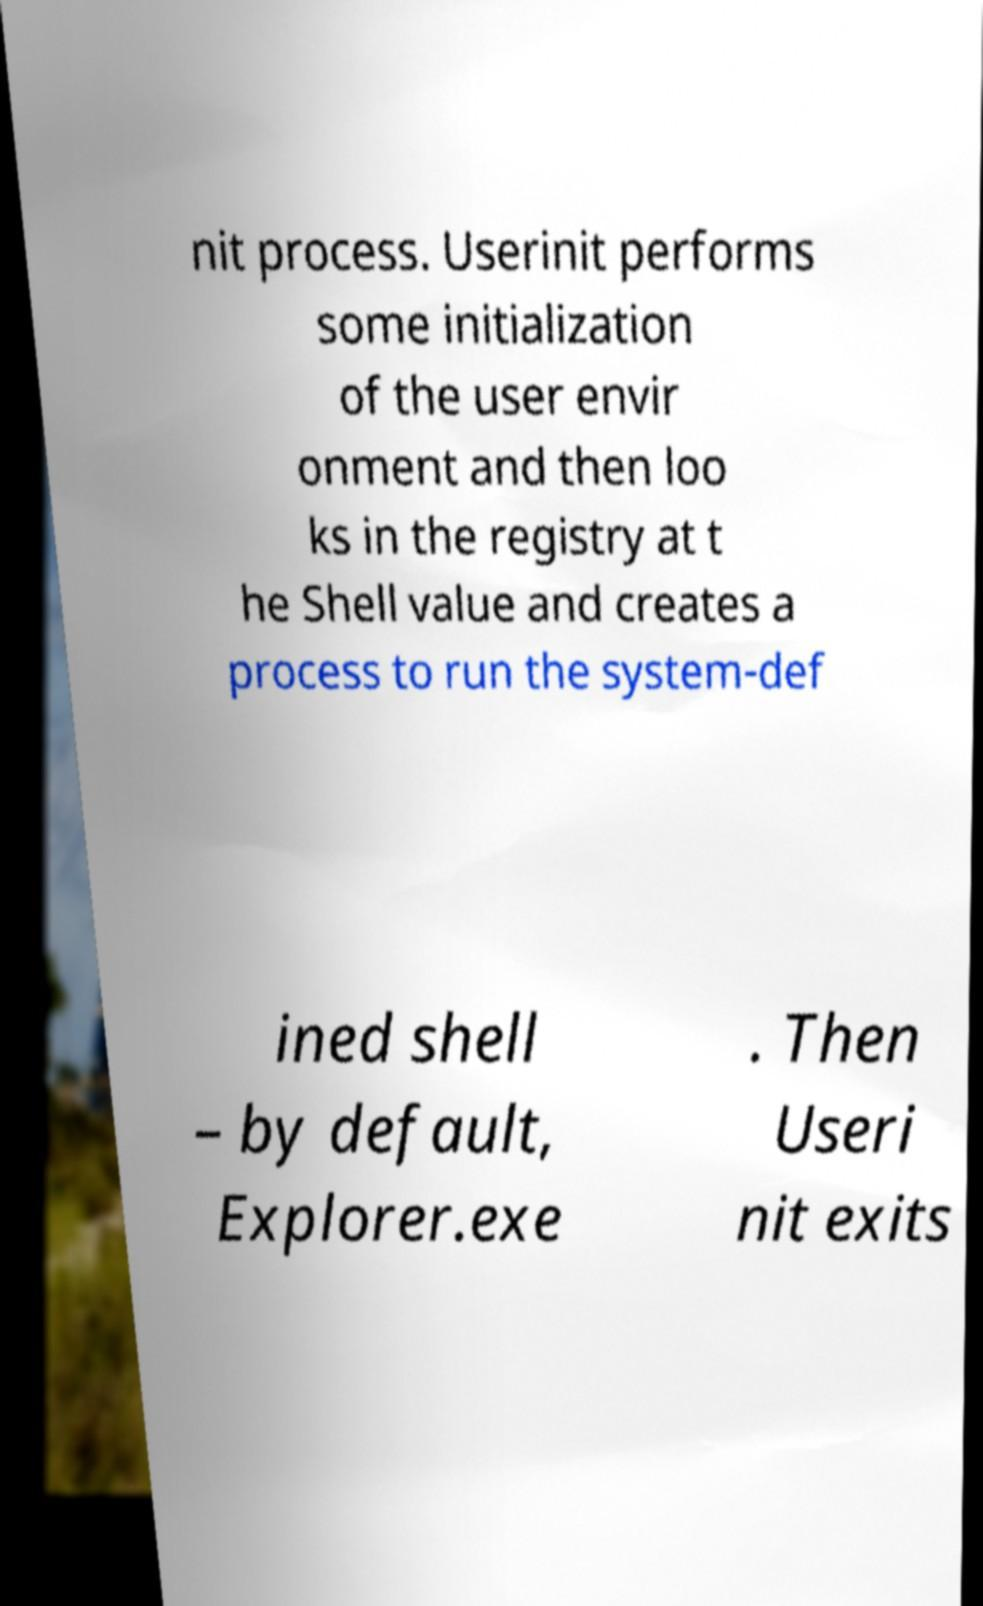I need the written content from this picture converted into text. Can you do that? nit process. Userinit performs some initialization of the user envir onment and then loo ks in the registry at t he Shell value and creates a process to run the system-def ined shell – by default, Explorer.exe . Then Useri nit exits 